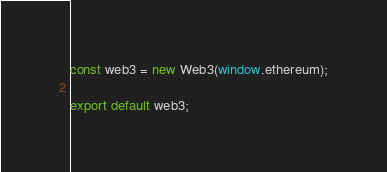Convert code to text. <code><loc_0><loc_0><loc_500><loc_500><_JavaScript_>
const web3 = new Web3(window.ethereum);

export default web3;</code> 